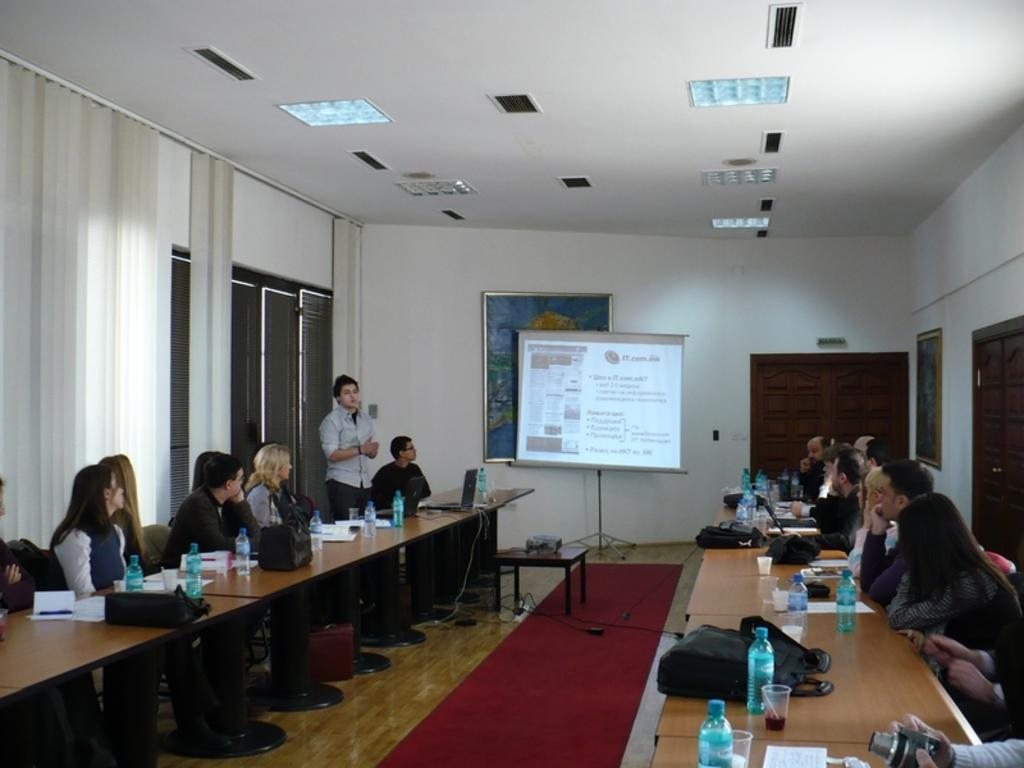What are the people in the image doing? The people in the image are sitting on chairs. Can you describe the man's position in the image? There is a man standing on the left side of the image. What can be seen on the table in the image? There are water bottles on a table in the image. What type of sticks are being used to make a statement in the image? There are no sticks or statements being made in the image. 